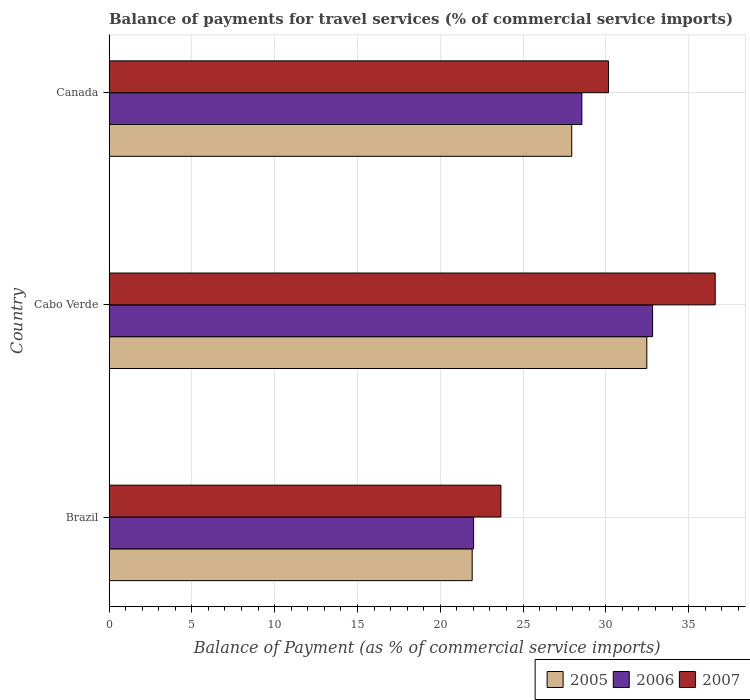How many different coloured bars are there?
Make the answer very short. 3. How many groups of bars are there?
Offer a terse response. 3. Are the number of bars on each tick of the Y-axis equal?
Provide a short and direct response. Yes. How many bars are there on the 3rd tick from the bottom?
Provide a short and direct response. 3. In how many cases, is the number of bars for a given country not equal to the number of legend labels?
Your response must be concise. 0. What is the balance of payments for travel services in 2005 in Cabo Verde?
Offer a terse response. 32.47. Across all countries, what is the maximum balance of payments for travel services in 2005?
Your answer should be compact. 32.47. Across all countries, what is the minimum balance of payments for travel services in 2007?
Offer a very short reply. 23.66. In which country was the balance of payments for travel services in 2007 maximum?
Give a very brief answer. Cabo Verde. What is the total balance of payments for travel services in 2006 in the graph?
Your answer should be very brief. 83.39. What is the difference between the balance of payments for travel services in 2006 in Cabo Verde and that in Canada?
Your answer should be very brief. 4.27. What is the difference between the balance of payments for travel services in 2005 in Canada and the balance of payments for travel services in 2007 in Cabo Verde?
Give a very brief answer. -8.66. What is the average balance of payments for travel services in 2005 per country?
Make the answer very short. 27.45. What is the difference between the balance of payments for travel services in 2006 and balance of payments for travel services in 2005 in Canada?
Provide a succinct answer. 0.61. What is the ratio of the balance of payments for travel services in 2006 in Brazil to that in Cabo Verde?
Make the answer very short. 0.67. Is the difference between the balance of payments for travel services in 2006 in Brazil and Cabo Verde greater than the difference between the balance of payments for travel services in 2005 in Brazil and Cabo Verde?
Your response must be concise. No. What is the difference between the highest and the second highest balance of payments for travel services in 2007?
Provide a succinct answer. 6.44. What is the difference between the highest and the lowest balance of payments for travel services in 2005?
Your answer should be very brief. 10.55. Is the sum of the balance of payments for travel services in 2007 in Brazil and Cabo Verde greater than the maximum balance of payments for travel services in 2005 across all countries?
Give a very brief answer. Yes. What does the 3rd bar from the bottom in Cabo Verde represents?
Ensure brevity in your answer.  2007. How many bars are there?
Offer a very short reply. 9. Are the values on the major ticks of X-axis written in scientific E-notation?
Give a very brief answer. No. Does the graph contain grids?
Offer a very short reply. Yes. Where does the legend appear in the graph?
Make the answer very short. Bottom right. What is the title of the graph?
Make the answer very short. Balance of payments for travel services (% of commercial service imports). What is the label or title of the X-axis?
Offer a very short reply. Balance of Payment (as % of commercial service imports). What is the label or title of the Y-axis?
Provide a short and direct response. Country. What is the Balance of Payment (as % of commercial service imports) in 2005 in Brazil?
Give a very brief answer. 21.93. What is the Balance of Payment (as % of commercial service imports) in 2006 in Brazil?
Ensure brevity in your answer.  22.01. What is the Balance of Payment (as % of commercial service imports) in 2007 in Brazil?
Offer a very short reply. 23.66. What is the Balance of Payment (as % of commercial service imports) in 2005 in Cabo Verde?
Your answer should be compact. 32.47. What is the Balance of Payment (as % of commercial service imports) in 2006 in Cabo Verde?
Provide a short and direct response. 32.82. What is the Balance of Payment (as % of commercial service imports) of 2007 in Cabo Verde?
Offer a very short reply. 36.6. What is the Balance of Payment (as % of commercial service imports) in 2005 in Canada?
Your answer should be compact. 27.94. What is the Balance of Payment (as % of commercial service imports) of 2006 in Canada?
Ensure brevity in your answer.  28.55. What is the Balance of Payment (as % of commercial service imports) of 2007 in Canada?
Keep it short and to the point. 30.16. Across all countries, what is the maximum Balance of Payment (as % of commercial service imports) of 2005?
Provide a succinct answer. 32.47. Across all countries, what is the maximum Balance of Payment (as % of commercial service imports) of 2006?
Ensure brevity in your answer.  32.82. Across all countries, what is the maximum Balance of Payment (as % of commercial service imports) in 2007?
Offer a terse response. 36.6. Across all countries, what is the minimum Balance of Payment (as % of commercial service imports) in 2005?
Keep it short and to the point. 21.93. Across all countries, what is the minimum Balance of Payment (as % of commercial service imports) of 2006?
Provide a short and direct response. 22.01. Across all countries, what is the minimum Balance of Payment (as % of commercial service imports) of 2007?
Provide a short and direct response. 23.66. What is the total Balance of Payment (as % of commercial service imports) of 2005 in the graph?
Offer a terse response. 82.34. What is the total Balance of Payment (as % of commercial service imports) of 2006 in the graph?
Ensure brevity in your answer.  83.39. What is the total Balance of Payment (as % of commercial service imports) of 2007 in the graph?
Offer a terse response. 90.43. What is the difference between the Balance of Payment (as % of commercial service imports) of 2005 in Brazil and that in Cabo Verde?
Your answer should be compact. -10.55. What is the difference between the Balance of Payment (as % of commercial service imports) of 2006 in Brazil and that in Cabo Verde?
Your response must be concise. -10.81. What is the difference between the Balance of Payment (as % of commercial service imports) in 2007 in Brazil and that in Cabo Verde?
Offer a very short reply. -12.94. What is the difference between the Balance of Payment (as % of commercial service imports) of 2005 in Brazil and that in Canada?
Your answer should be compact. -6.01. What is the difference between the Balance of Payment (as % of commercial service imports) of 2006 in Brazil and that in Canada?
Your answer should be compact. -6.54. What is the difference between the Balance of Payment (as % of commercial service imports) in 2007 in Brazil and that in Canada?
Provide a short and direct response. -6.5. What is the difference between the Balance of Payment (as % of commercial service imports) in 2005 in Cabo Verde and that in Canada?
Keep it short and to the point. 4.53. What is the difference between the Balance of Payment (as % of commercial service imports) of 2006 in Cabo Verde and that in Canada?
Offer a terse response. 4.27. What is the difference between the Balance of Payment (as % of commercial service imports) in 2007 in Cabo Verde and that in Canada?
Ensure brevity in your answer.  6.44. What is the difference between the Balance of Payment (as % of commercial service imports) in 2005 in Brazil and the Balance of Payment (as % of commercial service imports) in 2006 in Cabo Verde?
Your answer should be compact. -10.89. What is the difference between the Balance of Payment (as % of commercial service imports) in 2005 in Brazil and the Balance of Payment (as % of commercial service imports) in 2007 in Cabo Verde?
Provide a short and direct response. -14.68. What is the difference between the Balance of Payment (as % of commercial service imports) in 2006 in Brazil and the Balance of Payment (as % of commercial service imports) in 2007 in Cabo Verde?
Make the answer very short. -14.59. What is the difference between the Balance of Payment (as % of commercial service imports) in 2005 in Brazil and the Balance of Payment (as % of commercial service imports) in 2006 in Canada?
Give a very brief answer. -6.62. What is the difference between the Balance of Payment (as % of commercial service imports) of 2005 in Brazil and the Balance of Payment (as % of commercial service imports) of 2007 in Canada?
Your response must be concise. -8.23. What is the difference between the Balance of Payment (as % of commercial service imports) of 2006 in Brazil and the Balance of Payment (as % of commercial service imports) of 2007 in Canada?
Provide a short and direct response. -8.15. What is the difference between the Balance of Payment (as % of commercial service imports) of 2005 in Cabo Verde and the Balance of Payment (as % of commercial service imports) of 2006 in Canada?
Your response must be concise. 3.92. What is the difference between the Balance of Payment (as % of commercial service imports) in 2005 in Cabo Verde and the Balance of Payment (as % of commercial service imports) in 2007 in Canada?
Give a very brief answer. 2.31. What is the difference between the Balance of Payment (as % of commercial service imports) in 2006 in Cabo Verde and the Balance of Payment (as % of commercial service imports) in 2007 in Canada?
Your response must be concise. 2.66. What is the average Balance of Payment (as % of commercial service imports) in 2005 per country?
Provide a succinct answer. 27.45. What is the average Balance of Payment (as % of commercial service imports) of 2006 per country?
Ensure brevity in your answer.  27.8. What is the average Balance of Payment (as % of commercial service imports) in 2007 per country?
Your answer should be compact. 30.14. What is the difference between the Balance of Payment (as % of commercial service imports) of 2005 and Balance of Payment (as % of commercial service imports) of 2006 in Brazil?
Offer a terse response. -0.09. What is the difference between the Balance of Payment (as % of commercial service imports) of 2005 and Balance of Payment (as % of commercial service imports) of 2007 in Brazil?
Give a very brief answer. -1.74. What is the difference between the Balance of Payment (as % of commercial service imports) of 2006 and Balance of Payment (as % of commercial service imports) of 2007 in Brazil?
Provide a short and direct response. -1.65. What is the difference between the Balance of Payment (as % of commercial service imports) of 2005 and Balance of Payment (as % of commercial service imports) of 2006 in Cabo Verde?
Offer a terse response. -0.35. What is the difference between the Balance of Payment (as % of commercial service imports) of 2005 and Balance of Payment (as % of commercial service imports) of 2007 in Cabo Verde?
Your answer should be very brief. -4.13. What is the difference between the Balance of Payment (as % of commercial service imports) in 2006 and Balance of Payment (as % of commercial service imports) in 2007 in Cabo Verde?
Offer a very short reply. -3.78. What is the difference between the Balance of Payment (as % of commercial service imports) of 2005 and Balance of Payment (as % of commercial service imports) of 2006 in Canada?
Your answer should be very brief. -0.61. What is the difference between the Balance of Payment (as % of commercial service imports) of 2005 and Balance of Payment (as % of commercial service imports) of 2007 in Canada?
Make the answer very short. -2.22. What is the difference between the Balance of Payment (as % of commercial service imports) of 2006 and Balance of Payment (as % of commercial service imports) of 2007 in Canada?
Give a very brief answer. -1.61. What is the ratio of the Balance of Payment (as % of commercial service imports) in 2005 in Brazil to that in Cabo Verde?
Ensure brevity in your answer.  0.68. What is the ratio of the Balance of Payment (as % of commercial service imports) of 2006 in Brazil to that in Cabo Verde?
Provide a short and direct response. 0.67. What is the ratio of the Balance of Payment (as % of commercial service imports) of 2007 in Brazil to that in Cabo Verde?
Give a very brief answer. 0.65. What is the ratio of the Balance of Payment (as % of commercial service imports) of 2005 in Brazil to that in Canada?
Your answer should be very brief. 0.78. What is the ratio of the Balance of Payment (as % of commercial service imports) of 2006 in Brazil to that in Canada?
Your answer should be compact. 0.77. What is the ratio of the Balance of Payment (as % of commercial service imports) in 2007 in Brazil to that in Canada?
Give a very brief answer. 0.78. What is the ratio of the Balance of Payment (as % of commercial service imports) of 2005 in Cabo Verde to that in Canada?
Make the answer very short. 1.16. What is the ratio of the Balance of Payment (as % of commercial service imports) in 2006 in Cabo Verde to that in Canada?
Keep it short and to the point. 1.15. What is the ratio of the Balance of Payment (as % of commercial service imports) of 2007 in Cabo Verde to that in Canada?
Your answer should be very brief. 1.21. What is the difference between the highest and the second highest Balance of Payment (as % of commercial service imports) of 2005?
Offer a very short reply. 4.53. What is the difference between the highest and the second highest Balance of Payment (as % of commercial service imports) in 2006?
Give a very brief answer. 4.27. What is the difference between the highest and the second highest Balance of Payment (as % of commercial service imports) of 2007?
Your answer should be compact. 6.44. What is the difference between the highest and the lowest Balance of Payment (as % of commercial service imports) of 2005?
Keep it short and to the point. 10.55. What is the difference between the highest and the lowest Balance of Payment (as % of commercial service imports) of 2006?
Ensure brevity in your answer.  10.81. What is the difference between the highest and the lowest Balance of Payment (as % of commercial service imports) of 2007?
Your response must be concise. 12.94. 